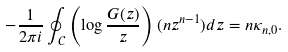Convert formula to latex. <formula><loc_0><loc_0><loc_500><loc_500>- \frac { 1 } { 2 \pi i } \oint _ { \mathcal { C } } \left ( \log \frac { G ( z ) } { z } \right ) ( n z ^ { n - 1 } ) d z = n \kappa _ { n , 0 } .</formula> 